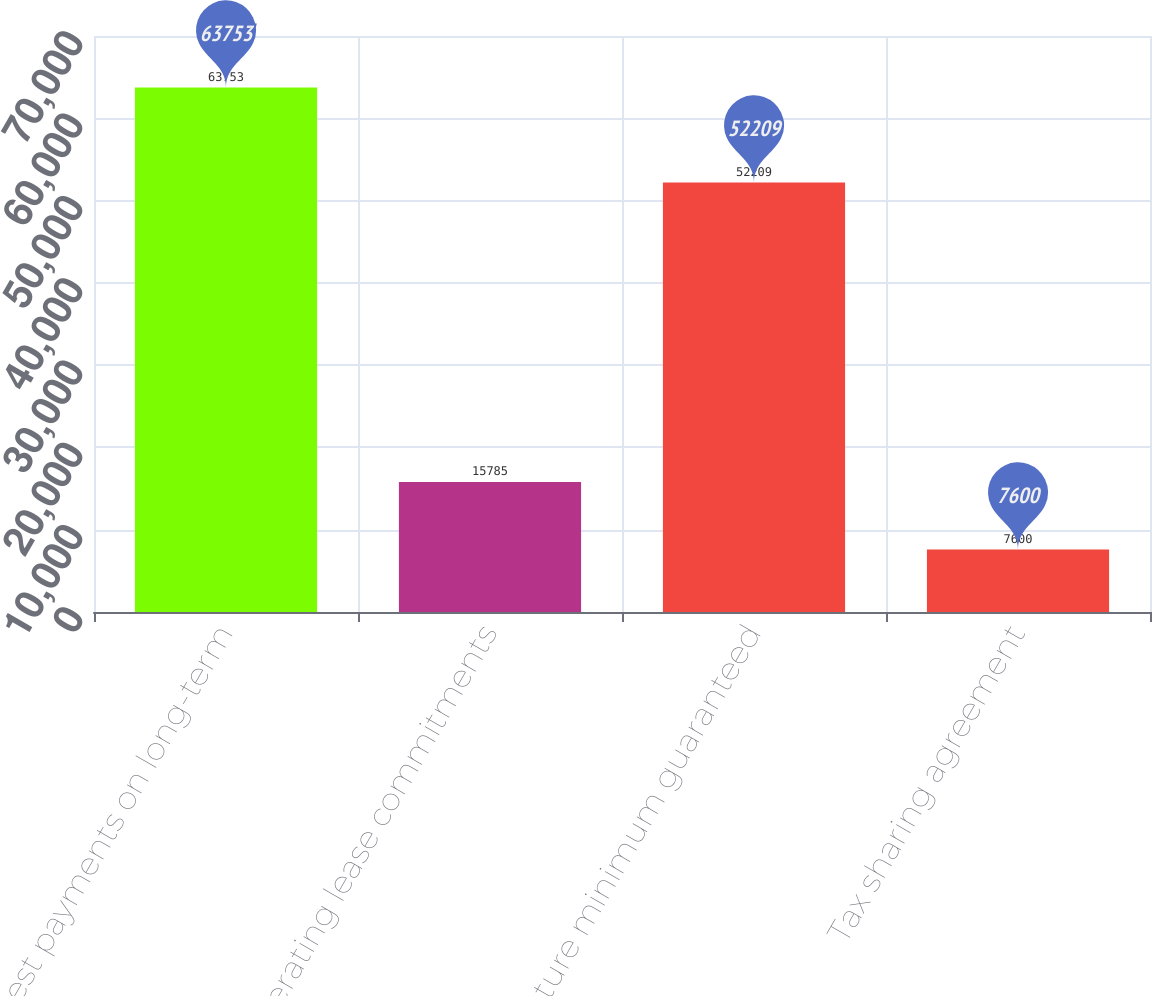Convert chart to OTSL. <chart><loc_0><loc_0><loc_500><loc_500><bar_chart><fcel>Interest payments on long-term<fcel>Operating lease commitments<fcel>Future minimum guaranteed<fcel>Tax sharing agreement<nl><fcel>63753<fcel>15785<fcel>52209<fcel>7600<nl></chart> 